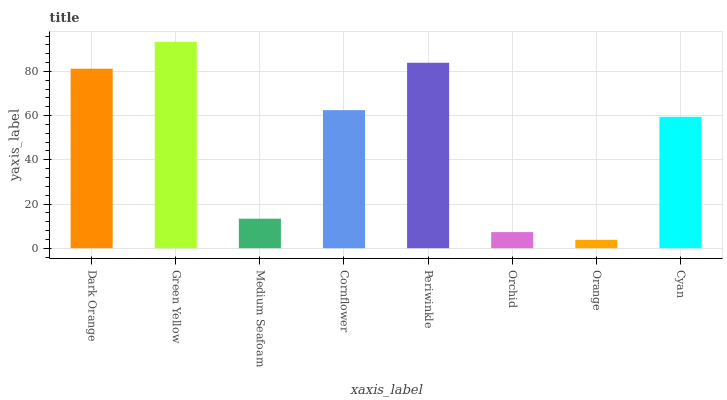Is Orange the minimum?
Answer yes or no. Yes. Is Green Yellow the maximum?
Answer yes or no. Yes. Is Medium Seafoam the minimum?
Answer yes or no. No. Is Medium Seafoam the maximum?
Answer yes or no. No. Is Green Yellow greater than Medium Seafoam?
Answer yes or no. Yes. Is Medium Seafoam less than Green Yellow?
Answer yes or no. Yes. Is Medium Seafoam greater than Green Yellow?
Answer yes or no. No. Is Green Yellow less than Medium Seafoam?
Answer yes or no. No. Is Cornflower the high median?
Answer yes or no. Yes. Is Cyan the low median?
Answer yes or no. Yes. Is Green Yellow the high median?
Answer yes or no. No. Is Orchid the low median?
Answer yes or no. No. 